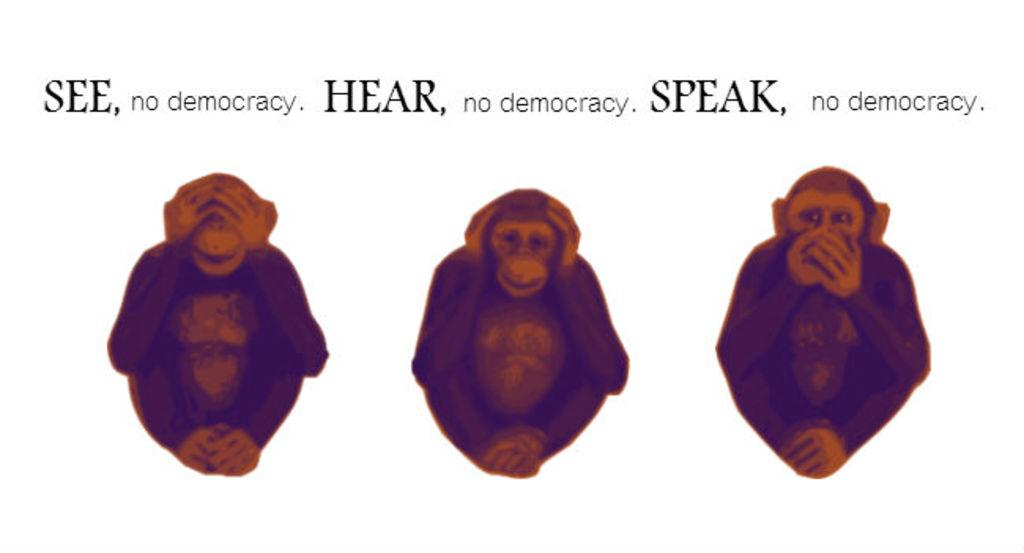How many monkeys are in the image? There are three monkeys in the image. What is each monkey doing in the image? The first monkey is covering its eyes, the second monkey is covering its ears, and the third monkey is covering its mouth. What is written at the top of the image? There is text written at the top of the image. What type of pets are attacking the monkeys in the image? There are no pets or attacks depicted in the image; it features three monkeys covering their eyes, ears, and mouth, with text written at the top. 